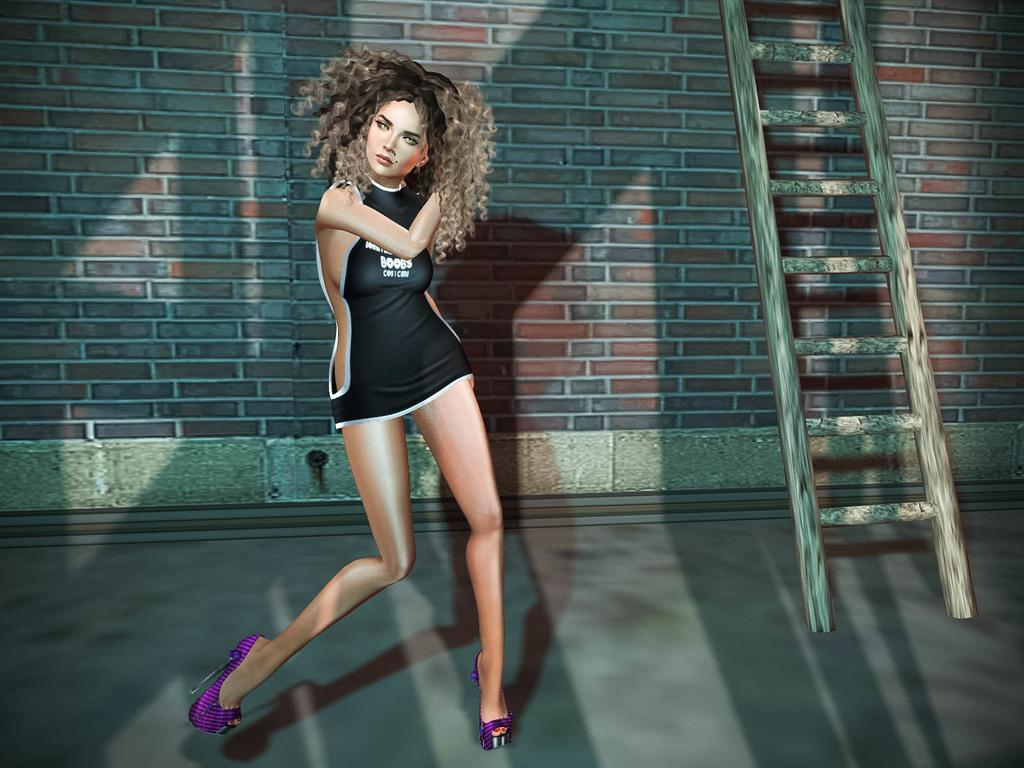Provide a one-sentence caption for the provided image. A woman dances whilst wearing a short dress with Boobs written on it. 